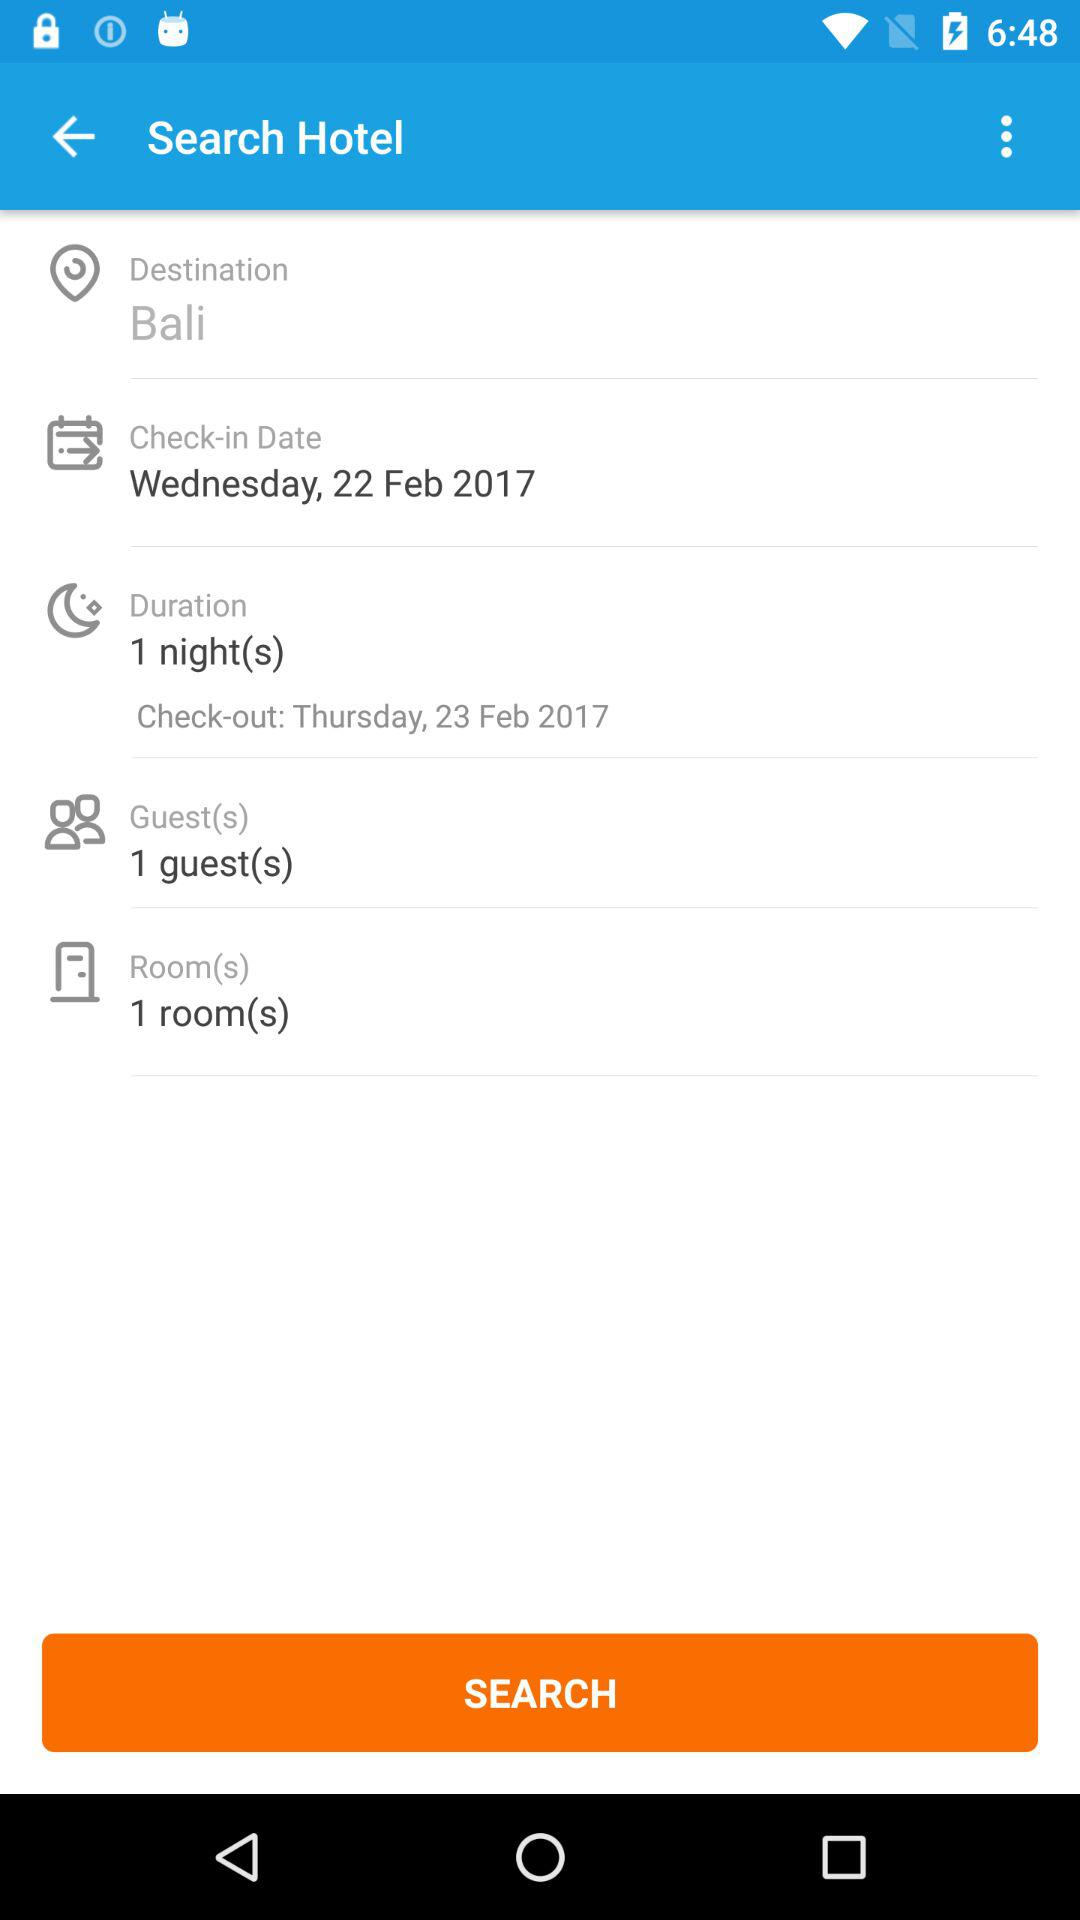How many guests are selected? The number of selected guests is 1. 